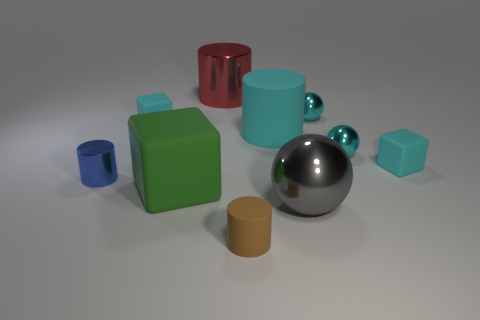What time of day does the lighting in this image suggest? The lighting in the image doesn't provide clear indications of time of day. It appears to be a controlled environment, possibly a studio setting, where the lighting is artificial and designed to highlight the objects without casting strong shadows. 